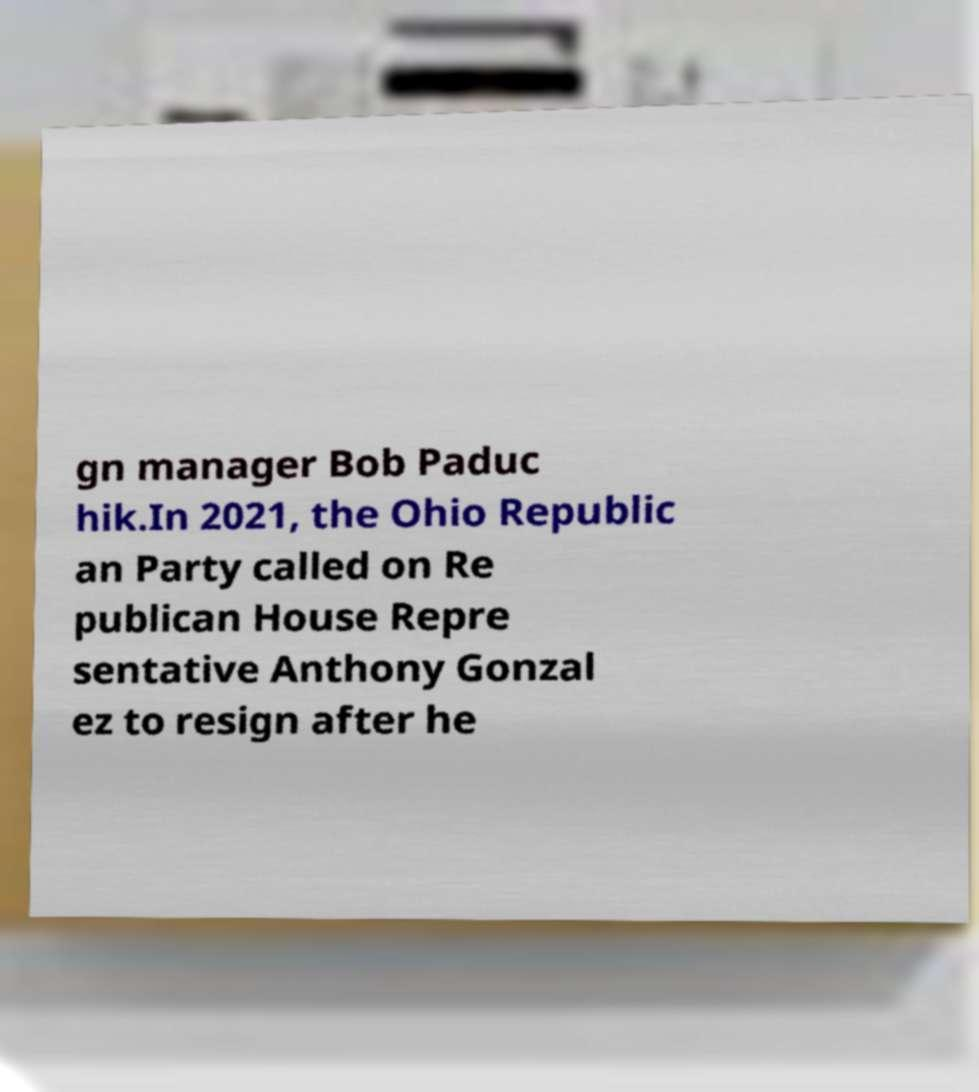Can you read and provide the text displayed in the image?This photo seems to have some interesting text. Can you extract and type it out for me? gn manager Bob Paduc hik.In 2021, the Ohio Republic an Party called on Re publican House Repre sentative Anthony Gonzal ez to resign after he 